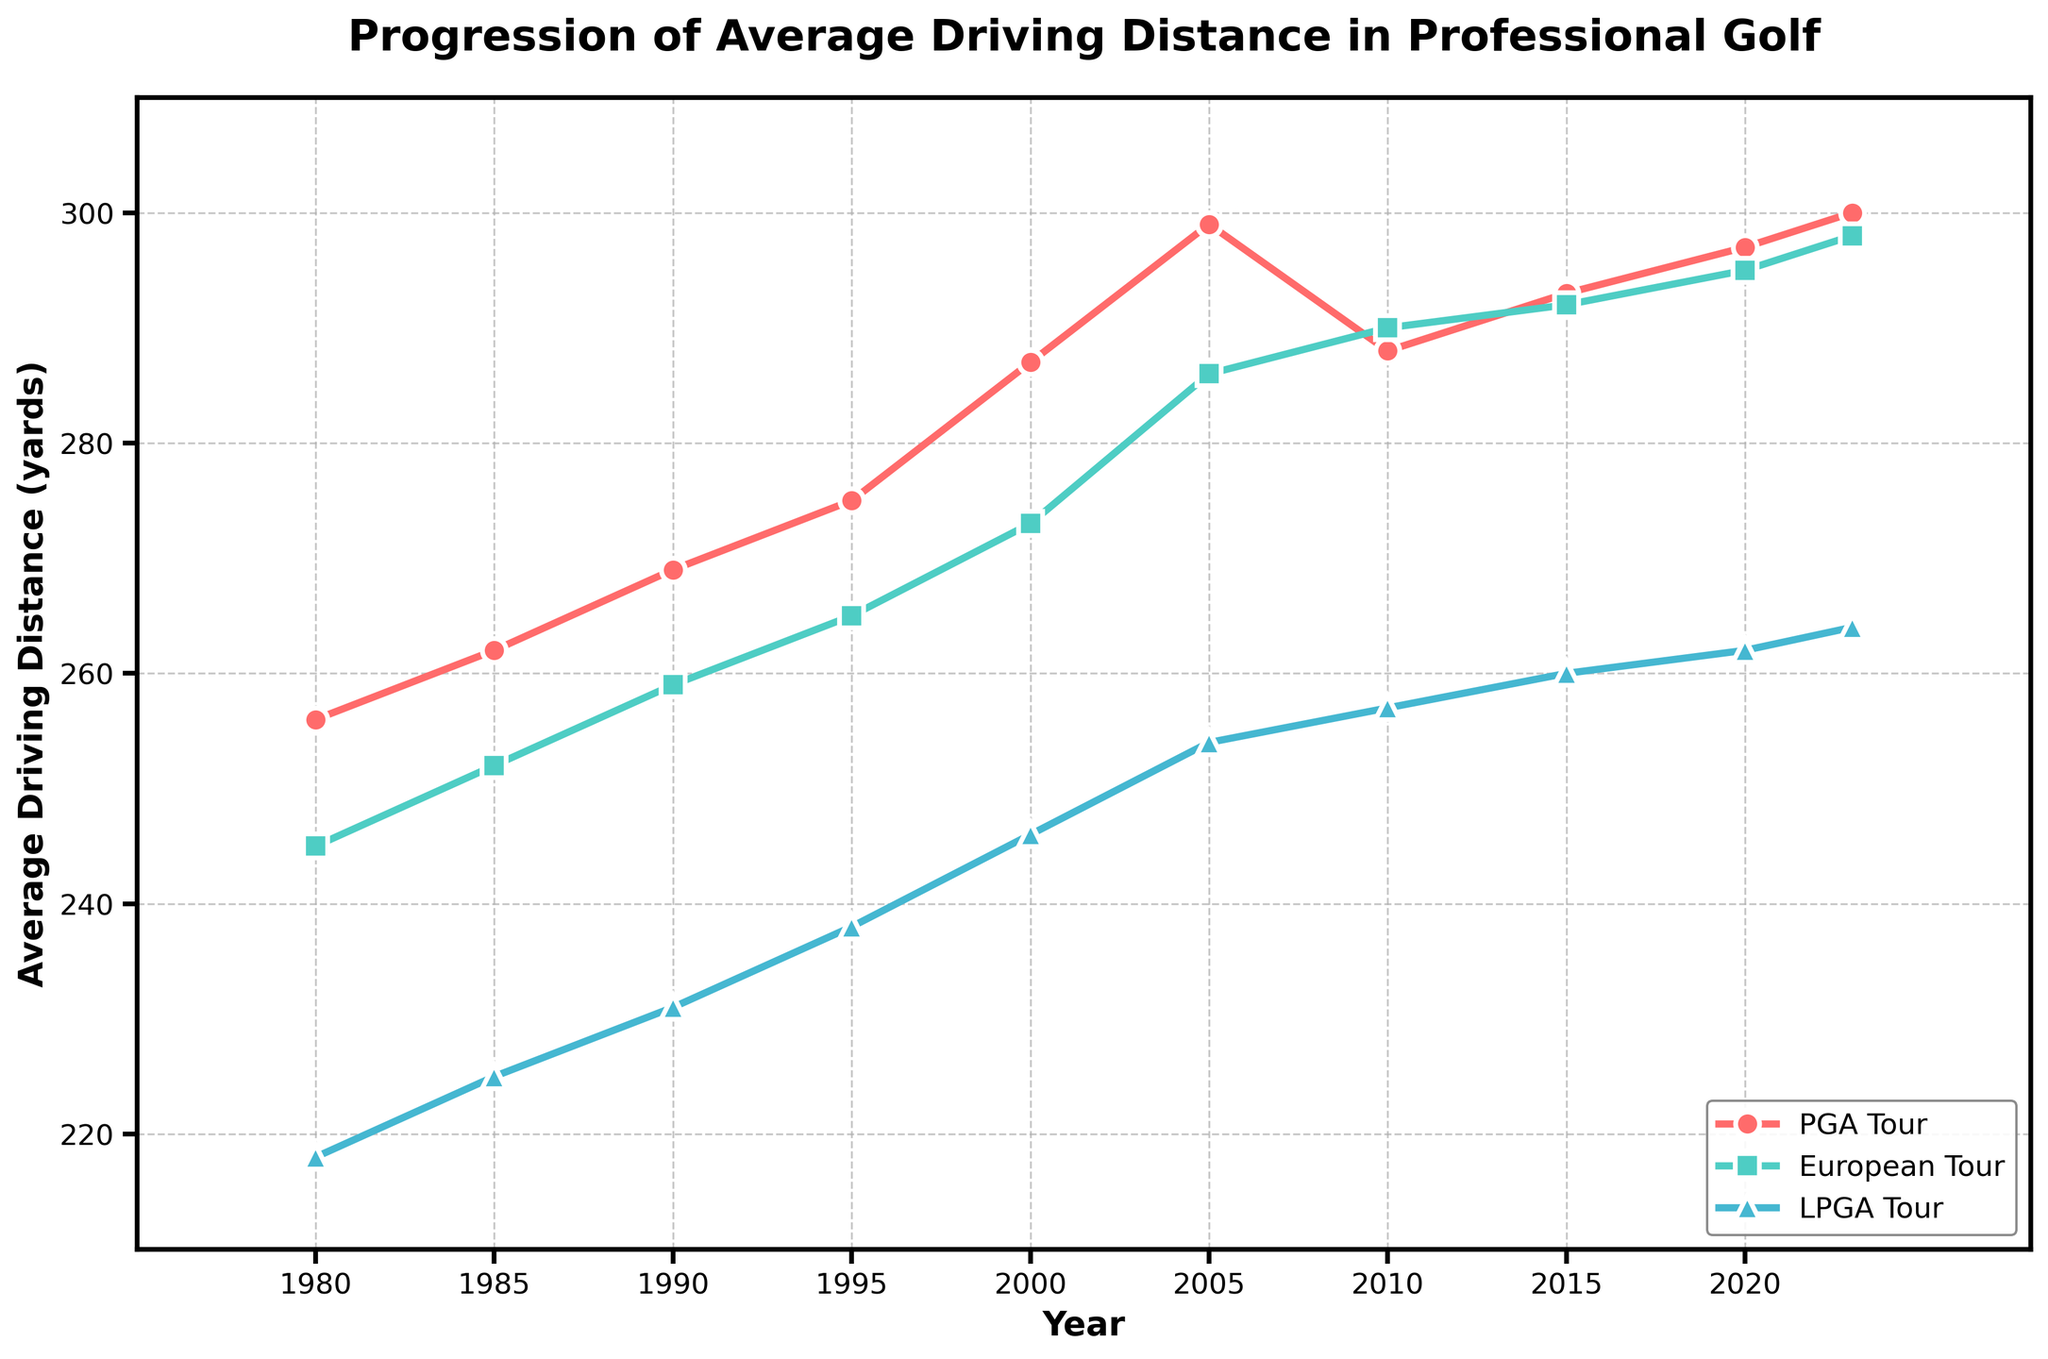What was the average driving distance for the PGA Tour in 2005? Locate the point for the year 2005 on the x-axis and follow it up to the PGA Tour line (red). The value is the average driving distance.
Answer: 299 yards Which tour had the higher average driving distance in 2010, PGA Tour or European Tour? Look at the data points for the year 2010 for both the PGA Tour (red line) and European Tour (green line). Compare their heights.
Answer: European Tour By how many yards did the LPGA Tour's average driving distance increase from 1980 to 2023? Note the average driving distance for LPGA Tour in 1980 (218 yards) and in 2023 (264 yards). Subtract the 1980 value from the 2023 value. 264 - 218
Answer: 46 yards What's the overall trend for the European Tour's average driving distance? Observe the green line representing the European Tour from 1980 to 2023. Notice how it generally increases over time.
Answer: Increasing In which year did the PGA Tour have the highest average driving distance? Find the highest point on the red line. The x-axis value corresponding to this point is the year.
Answer: 2023 What is the difference in average driving distance between the LPGA Tour and PGA Tour in 2023? Note the values for both tours in 2023: LPGA Tour (264 yards) and PGA Tour (300 yards). Subtract the LPGA Tour value from the PGA Tour value. 300 - 264
Answer: 36 yards How much did the average driving distance for the European Tour change between 2005 and 2010? Note the values for the European Tour in 2005 (286 yards) and in 2010 (290 yards). Subtract the 2005 value from the 2010 value. 290 - 286
Answer: 4 yards Which tour showed the smallest increase in average driving distance from 1980 to 2023? Calculate the increase for each tour: 
PGA Tour: 300 - 256 = 44 yards
European Tour: 298 - 245 = 53 yards
LPGA Tour: 264 - 218 = 46 yards
Compare the values.
Answer: PGA Tour What was the average yearly increase in driving distance for the LPGA Tour between 1980 and 2023? Calculate the total increase from 1980 to 2023 (46 yards), then divide by the number of years (2023 - 1980 = 43 years). 46 / 43
Answer: ~1.07 yards/year During which period did the PGA Tour experience the steepest increase in average driving distance? Observe the red line and identify the period with the sharpest upward slope. Measure the changes between 1980-1985, 1985-1990, 1990-1995, 1995-2000, 2000-2005.
Answer: 1995-2000 